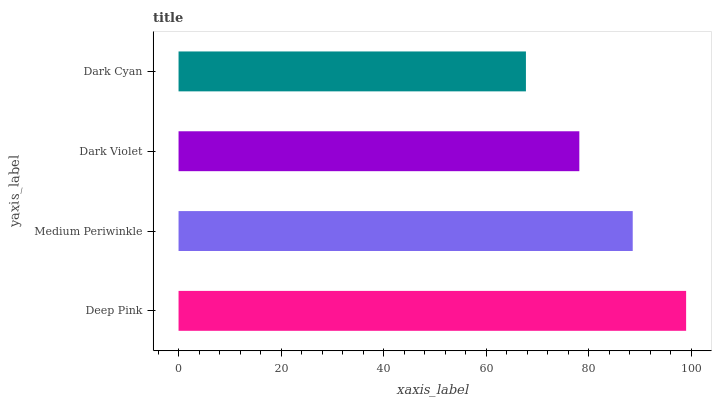Is Dark Cyan the minimum?
Answer yes or no. Yes. Is Deep Pink the maximum?
Answer yes or no. Yes. Is Medium Periwinkle the minimum?
Answer yes or no. No. Is Medium Periwinkle the maximum?
Answer yes or no. No. Is Deep Pink greater than Medium Periwinkle?
Answer yes or no. Yes. Is Medium Periwinkle less than Deep Pink?
Answer yes or no. Yes. Is Medium Periwinkle greater than Deep Pink?
Answer yes or no. No. Is Deep Pink less than Medium Periwinkle?
Answer yes or no. No. Is Medium Periwinkle the high median?
Answer yes or no. Yes. Is Dark Violet the low median?
Answer yes or no. Yes. Is Deep Pink the high median?
Answer yes or no. No. Is Medium Periwinkle the low median?
Answer yes or no. No. 